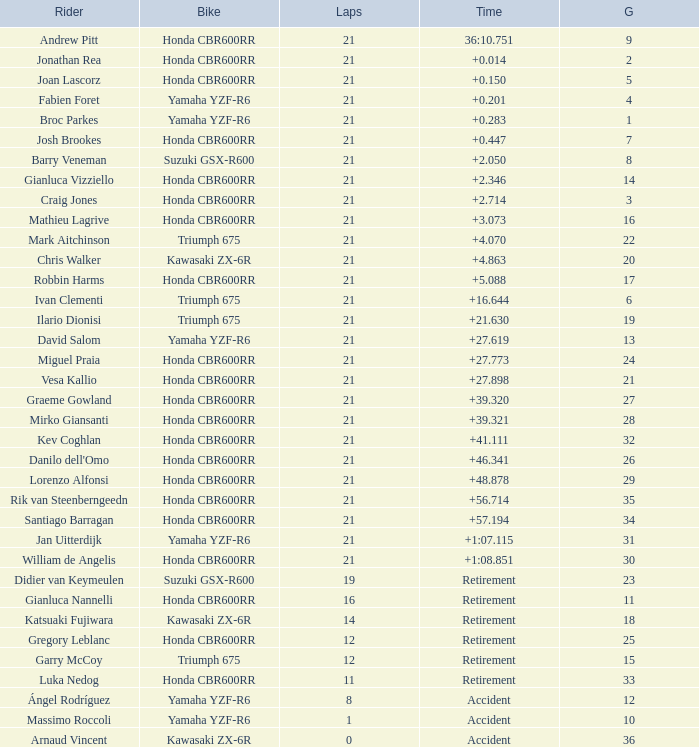What driver had the highest grid position with a time of +0.283? 1.0. 